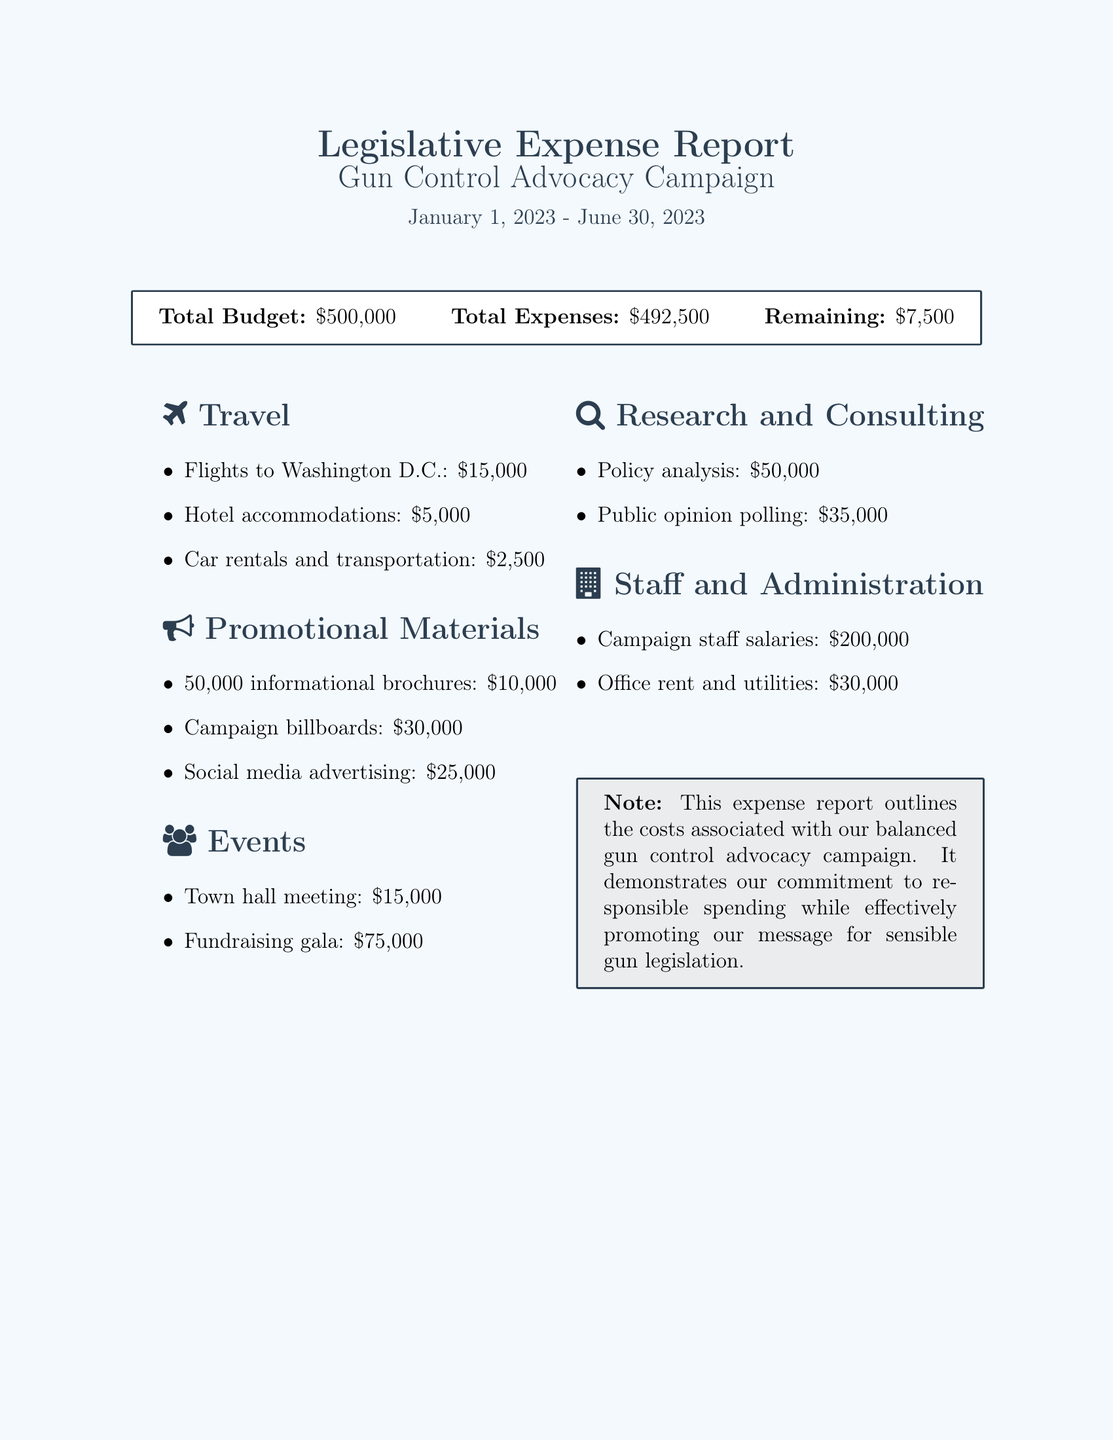what is the total budget? The total budget is explicitly stated at the beginning of the expense report.
Answer: $500,000 how much was spent on promotional materials? The total amount spent on promotional materials is the sum of all listed items in that category.
Answer: $65,000 what is the remaining budget? The remaining budget is calculated by subtracting total expenses from total budget, which is provided in the report.
Answer: $7,500 how much was allocated for events? The total amount allocated for events is the sum of expenses listed under the events section.
Answer: $90,000 what was the cost of public opinion polling? The cost of public opinion polling is specified in the research and consulting section.
Answer: $35,000 how much was spent on town hall meetings? The expense for the town hall meeting is explicitly listed in the events section.
Answer: $15,000 what is the total expense amount? The total expense amount is stated at the top of the expense report.
Answer: $492,500 how much was allocated for staff salaries? The amount for campaign staff salaries is clearly listed in the staff and administration section.
Answer: $200,000 what is the date range covered in this report? The date range is indicated in the title of the report.
Answer: January 1, 2023 - June 30, 2023 